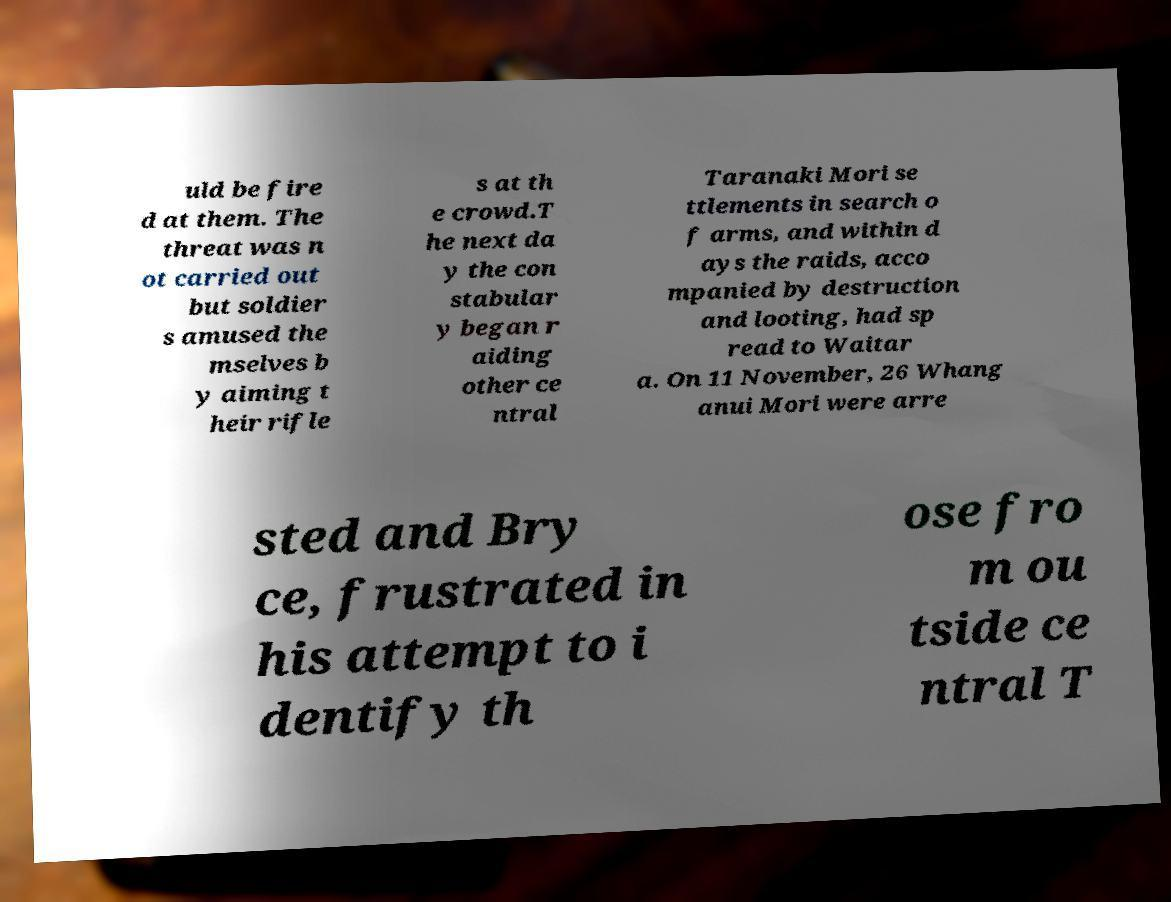Please identify and transcribe the text found in this image. uld be fire d at them. The threat was n ot carried out but soldier s amused the mselves b y aiming t heir rifle s at th e crowd.T he next da y the con stabular y began r aiding other ce ntral Taranaki Mori se ttlements in search o f arms, and within d ays the raids, acco mpanied by destruction and looting, had sp read to Waitar a. On 11 November, 26 Whang anui Mori were arre sted and Bry ce, frustrated in his attempt to i dentify th ose fro m ou tside ce ntral T 